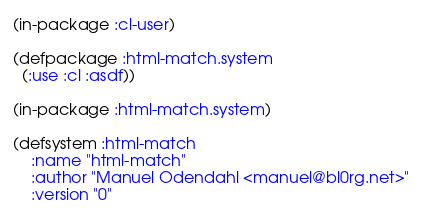Convert code to text. <code><loc_0><loc_0><loc_500><loc_500><_Lisp_>(in-package :cl-user)

(defpackage :html-match.system
  (:use :cl :asdf))

(in-package :html-match.system)

(defsystem :html-match
    :name "html-match"
    :author "Manuel Odendahl <manuel@bl0rg.net>"
    :version "0"</code> 